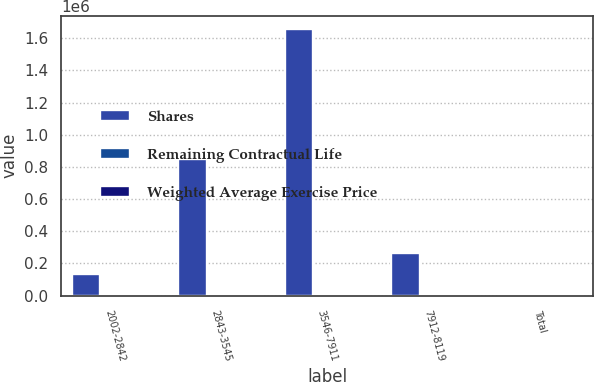Convert chart to OTSL. <chart><loc_0><loc_0><loc_500><loc_500><stacked_bar_chart><ecel><fcel>2002-2842<fcel>2843-3545<fcel>3546-7911<fcel>7912-8119<fcel>Total<nl><fcel>Shares<fcel>136202<fcel>851948<fcel>1.65715e+06<fcel>264969<fcel>36.135<nl><fcel>Remaining Contractual Life<fcel>21.49<fcel>33.04<fcel>39.23<fcel>80.47<fcel>40.33<nl><fcel>Weighted Average Exercise Price<fcel>1.29<fcel>3.56<fcel>4.04<fcel>4.8<fcel>3.84<nl></chart> 